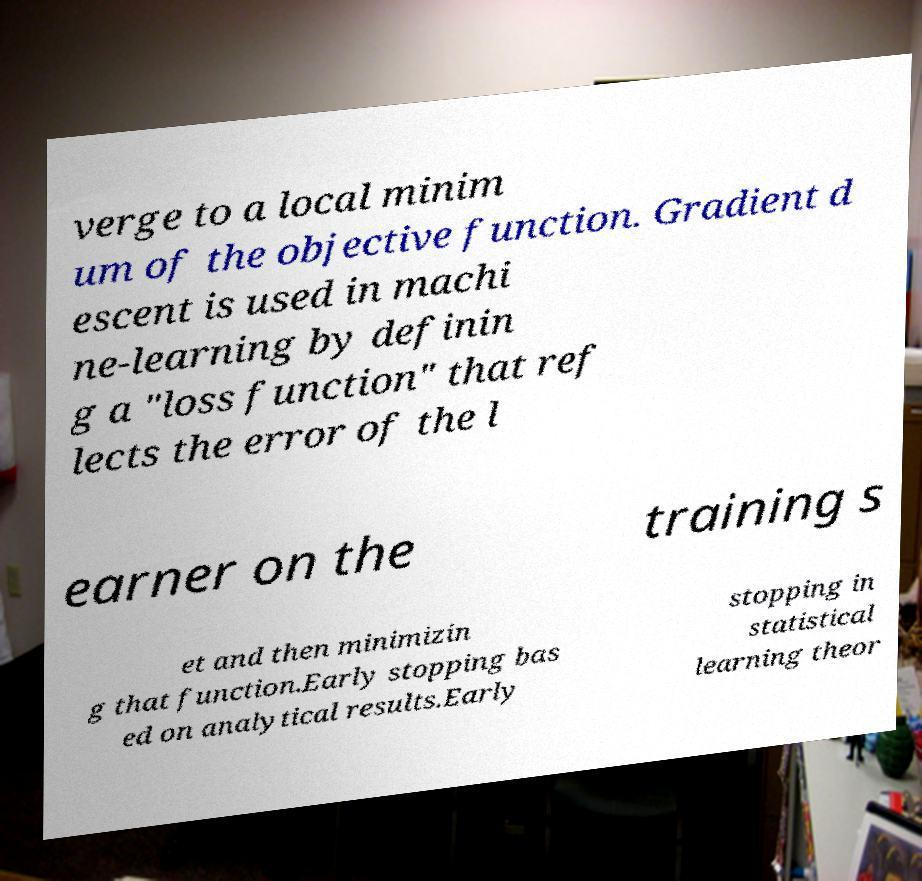What messages or text are displayed in this image? I need them in a readable, typed format. verge to a local minim um of the objective function. Gradient d escent is used in machi ne-learning by definin g a "loss function" that ref lects the error of the l earner on the training s et and then minimizin g that function.Early stopping bas ed on analytical results.Early stopping in statistical learning theor 